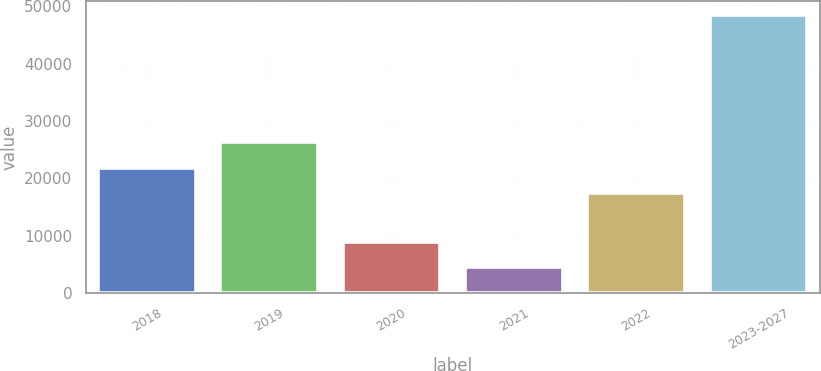<chart> <loc_0><loc_0><loc_500><loc_500><bar_chart><fcel>2018<fcel>2019<fcel>2020<fcel>2021<fcel>2022<fcel>2023-2027<nl><fcel>21900.6<fcel>26281.2<fcel>8989.6<fcel>4609<fcel>17520<fcel>48415<nl></chart> 